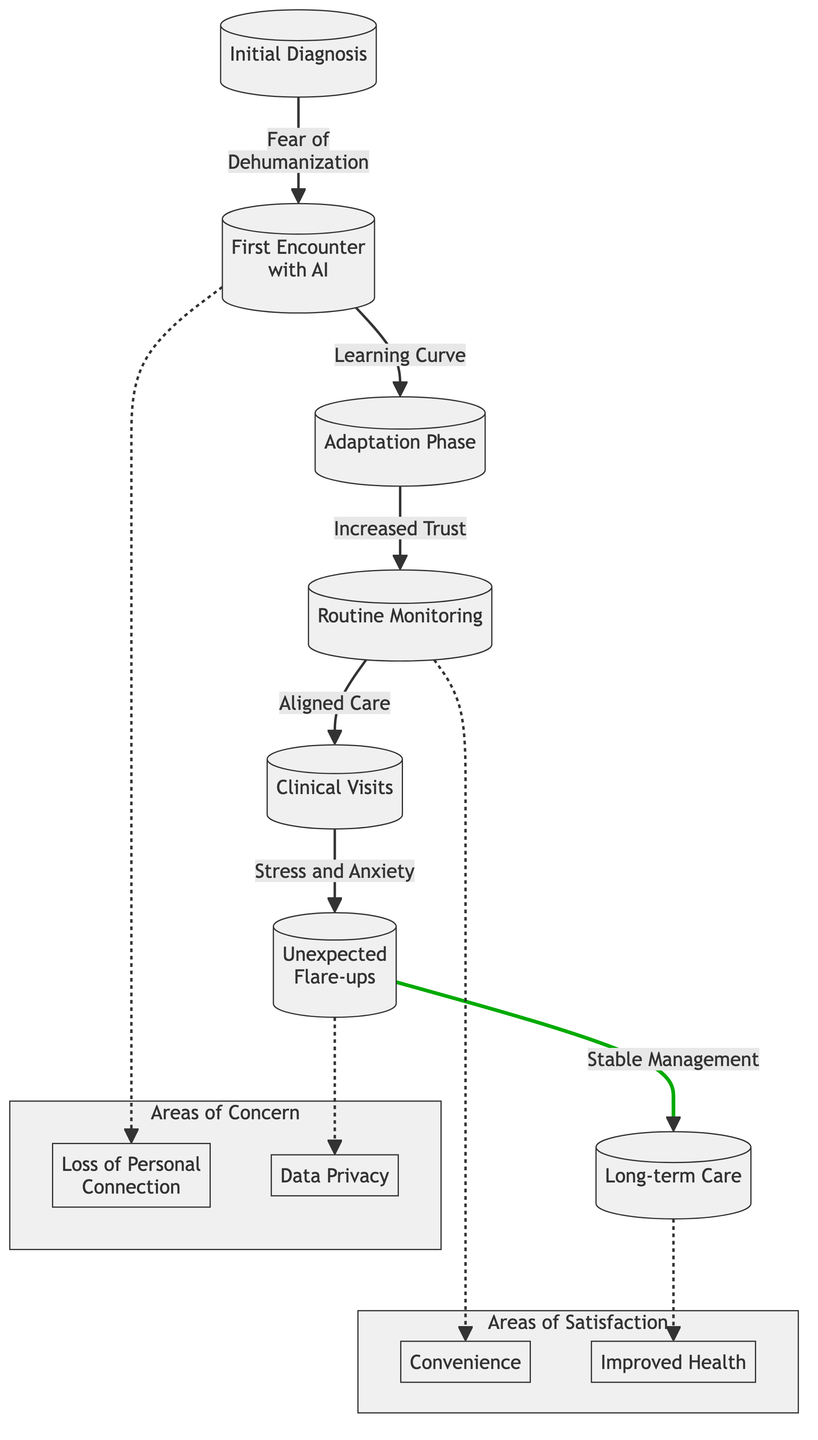What is the first stage in the emotional journey? The first stage is indicated as the starting node in the diagram, labeled "Initial Diagnosis."
Answer: Initial Diagnosis Which stage is associated with "Stable Management"? "Stable Management" is the terminal node in the flowchart and is linked to the previous stage "Unexpected Flare-ups."
Answer: Long-term Care How many areas of concern are presented in the diagram? By examining the labeled subgraph "Areas of Concern," we can see there are two nodes representing areas of concern in the diagram.
Answer: 2 What happens after the "First Encounter with AI"? The flow shows an arrow leading from "First Encounter with AI" to "Adaptation Phase," indicating this is the next stage in the journey.
Answer: Adaptation Phase Which stages highlight areas of satisfaction? The flowchart specifically marks "Routine Monitoring" and "Long-term Care" as stages that denote satisfaction through distinct color coding and labels.
Answer: Routine Monitoring, Long-term Care What is the primary concern associated with "Unexpected Flare-ups"? The flowchart includes a connection from "Unexpected Flare-ups" to the area of concern labeled "Data Privacy," indicating that this is a primary concern at this stage.
Answer: Data Privacy What is the emotional state during "Routine Monitoring"? The "Routine Monitoring" stage is highlighted as a place of satisfaction, specifically linked to the convenience provided in that phase.
Answer: Convenience How does the flow from "Adaptation Phase" to "Routine Monitoring" reflect trust? The positive transition from "Adaptation Phase" to "Routine Monitoring" suggests that increased trust facilitates a smoother journey, indicating satisfaction with care received.
Answer: Increased Trust 